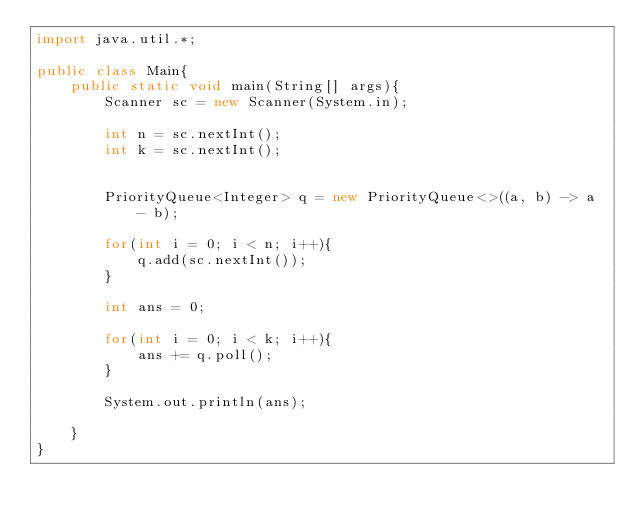<code> <loc_0><loc_0><loc_500><loc_500><_Java_>import java.util.*;

public class Main{
    public static void main(String[] args){
        Scanner sc = new Scanner(System.in);

        int n = sc.nextInt();
        int k = sc.nextInt();


        PriorityQueue<Integer> q = new PriorityQueue<>((a, b) -> a - b);

        for(int i = 0; i < n; i++){
            q.add(sc.nextInt());
        }

        int ans = 0;

        for(int i = 0; i < k; i++){
            ans += q.poll();
        }

        System.out.println(ans);

    }
}
</code> 